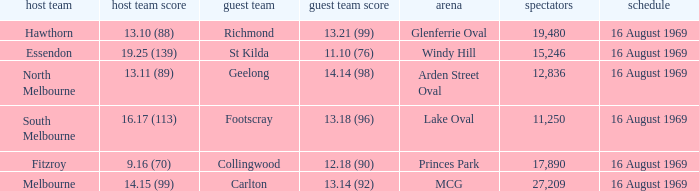What was the away team when the game was at Princes Park? Collingwood. 